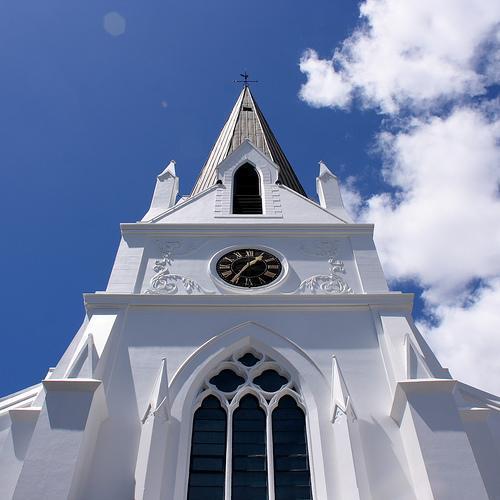How many clocks are in the picture?
Give a very brief answer. 1. 